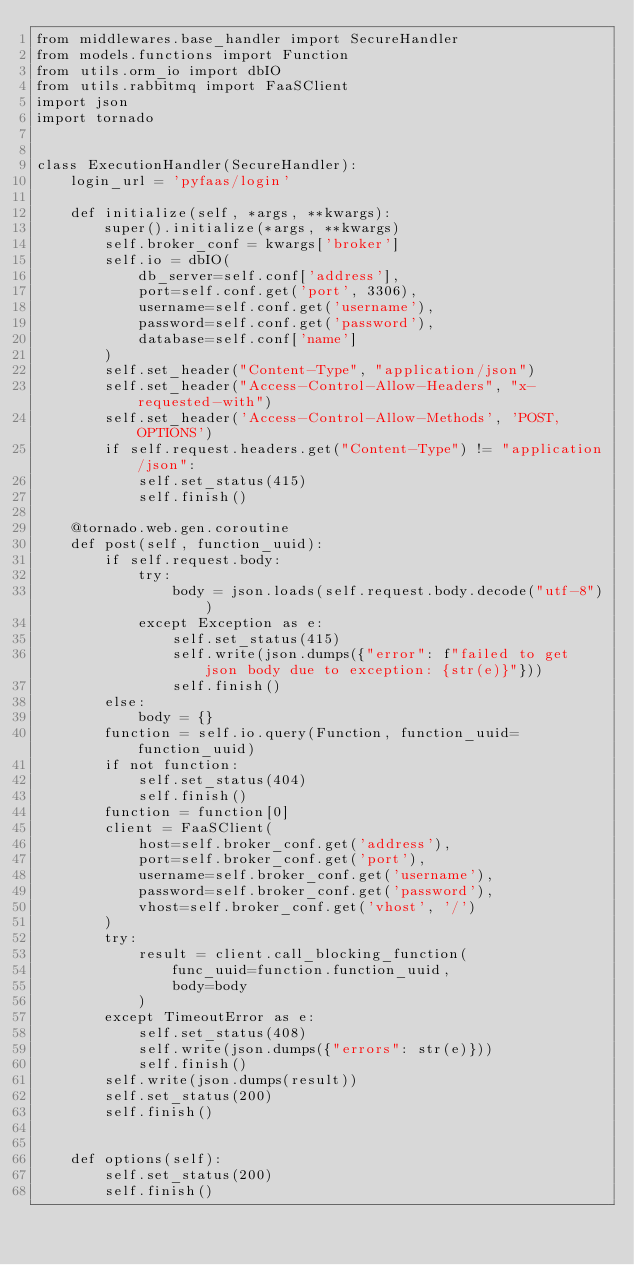Convert code to text. <code><loc_0><loc_0><loc_500><loc_500><_Python_>from middlewares.base_handler import SecureHandler
from models.functions import Function
from utils.orm_io import dbIO
from utils.rabbitmq import FaaSClient
import json
import tornado


class ExecutionHandler(SecureHandler):
    login_url = 'pyfaas/login'

    def initialize(self, *args, **kwargs):
        super().initialize(*args, **kwargs)
        self.broker_conf = kwargs['broker']
        self.io = dbIO(
            db_server=self.conf['address'],
            port=self.conf.get('port', 3306),
            username=self.conf.get('username'),
            password=self.conf.get('password'),
            database=self.conf['name']
        )
        self.set_header("Content-Type", "application/json")
        self.set_header("Access-Control-Allow-Headers", "x-requested-with")
        self.set_header('Access-Control-Allow-Methods', 'POST, OPTIONS')
        if self.request.headers.get("Content-Type") != "application/json":
            self.set_status(415)
            self.finish()

    @tornado.web.gen.coroutine
    def post(self, function_uuid):
        if self.request.body:
            try:
                body = json.loads(self.request.body.decode("utf-8"))
            except Exception as e:
                self.set_status(415)
                self.write(json.dumps({"error": f"failed to get json body due to exception: {str(e)}"}))
                self.finish()
        else:
            body = {}
        function = self.io.query(Function, function_uuid=function_uuid)
        if not function:
            self.set_status(404)
            self.finish()
        function = function[0]
        client = FaaSClient(
            host=self.broker_conf.get('address'),
            port=self.broker_conf.get('port'),
            username=self.broker_conf.get('username'),
            password=self.broker_conf.get('password'),
            vhost=self.broker_conf.get('vhost', '/')
        )
        try:
            result = client.call_blocking_function(
                func_uuid=function.function_uuid,
                body=body
            )
        except TimeoutError as e:
            self.set_status(408)
            self.write(json.dumps({"errors": str(e)}))
            self.finish()
        self.write(json.dumps(result))
        self.set_status(200)
        self.finish()


    def options(self):
        self.set_status(200)
        self.finish()
</code> 